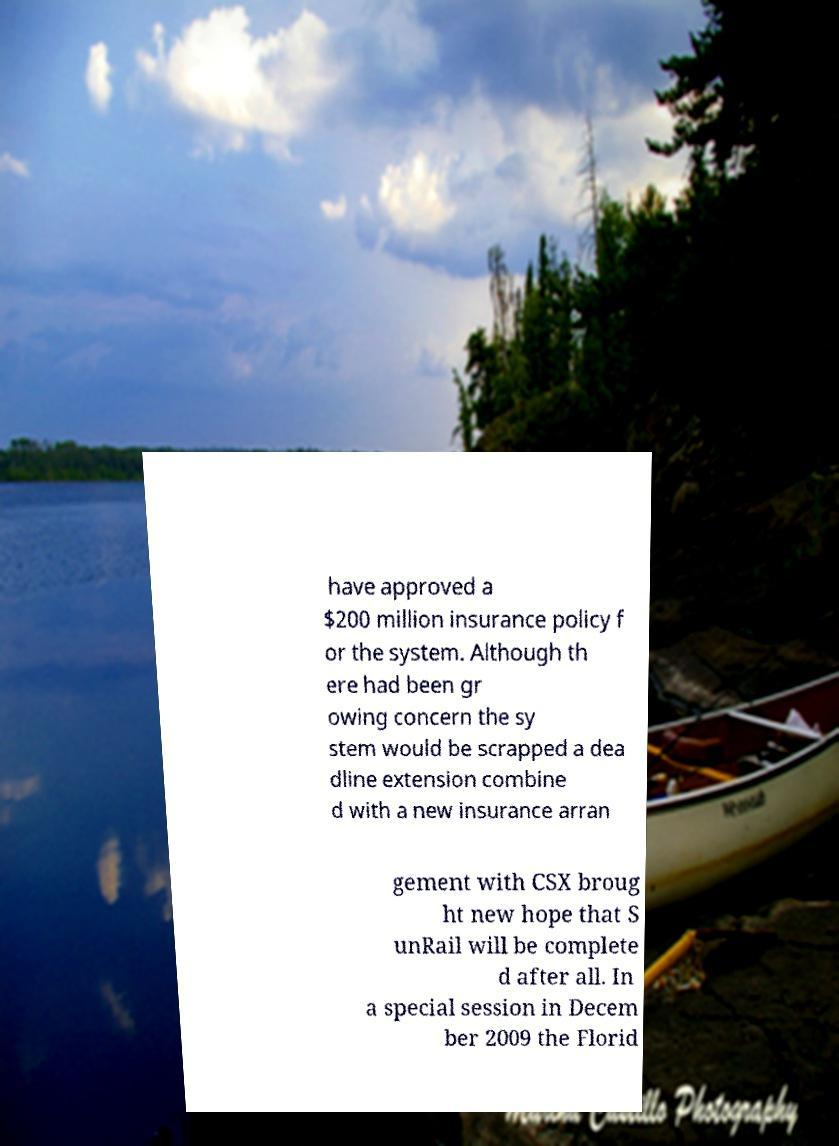I need the written content from this picture converted into text. Can you do that? have approved a $200 million insurance policy f or the system. Although th ere had been gr owing concern the sy stem would be scrapped a dea dline extension combine d with a new insurance arran gement with CSX broug ht new hope that S unRail will be complete d after all. In a special session in Decem ber 2009 the Florid 